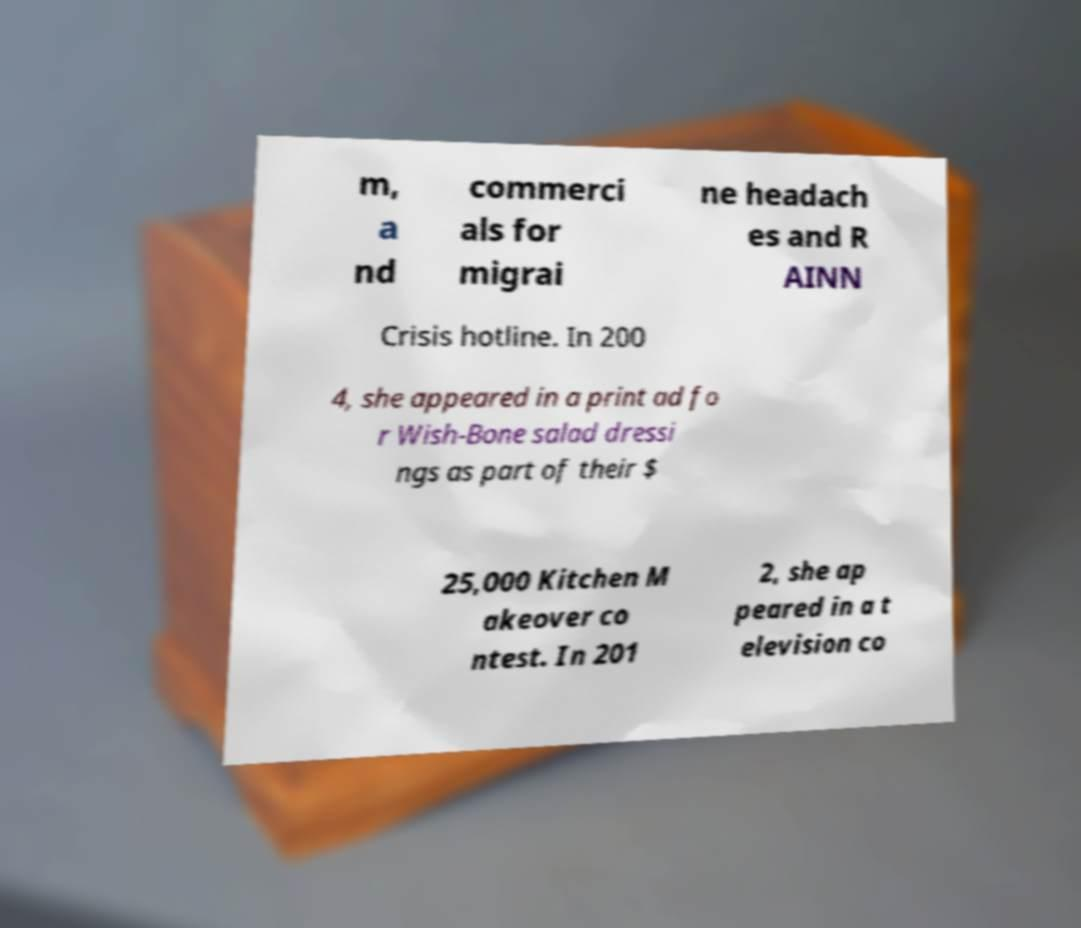Please identify and transcribe the text found in this image. m, a nd commerci als for migrai ne headach es and R AINN Crisis hotline. In 200 4, she appeared in a print ad fo r Wish-Bone salad dressi ngs as part of their $ 25,000 Kitchen M akeover co ntest. In 201 2, she ap peared in a t elevision co 